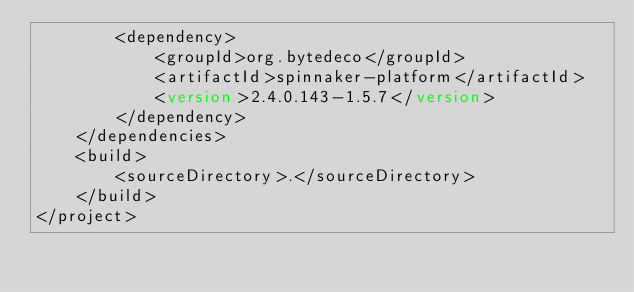<code> <loc_0><loc_0><loc_500><loc_500><_XML_>        <dependency>
            <groupId>org.bytedeco</groupId>
            <artifactId>spinnaker-platform</artifactId>
            <version>2.4.0.143-1.5.7</version>
        </dependency>
    </dependencies>
    <build>
        <sourceDirectory>.</sourceDirectory>
    </build>
</project>

</code> 